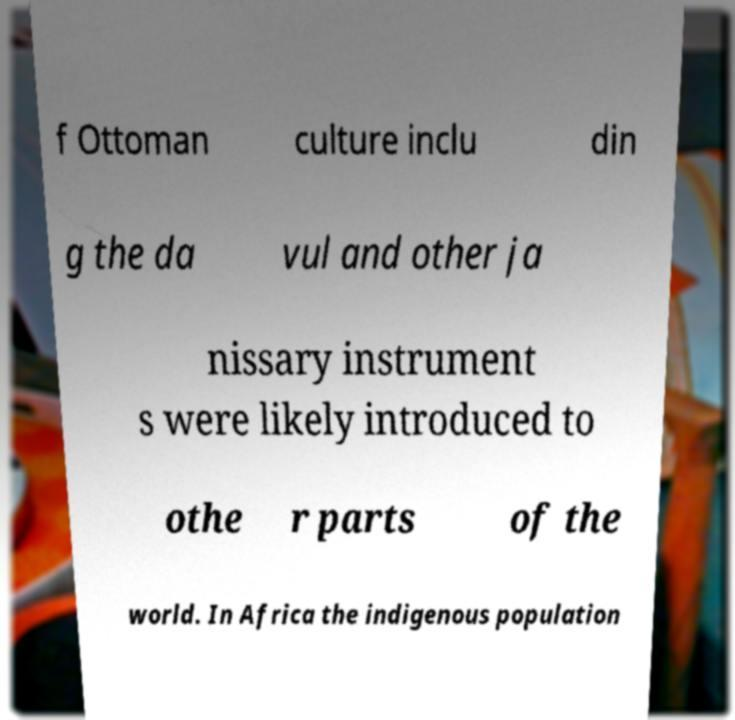There's text embedded in this image that I need extracted. Can you transcribe it verbatim? f Ottoman culture inclu din g the da vul and other ja nissary instrument s were likely introduced to othe r parts of the world. In Africa the indigenous population 